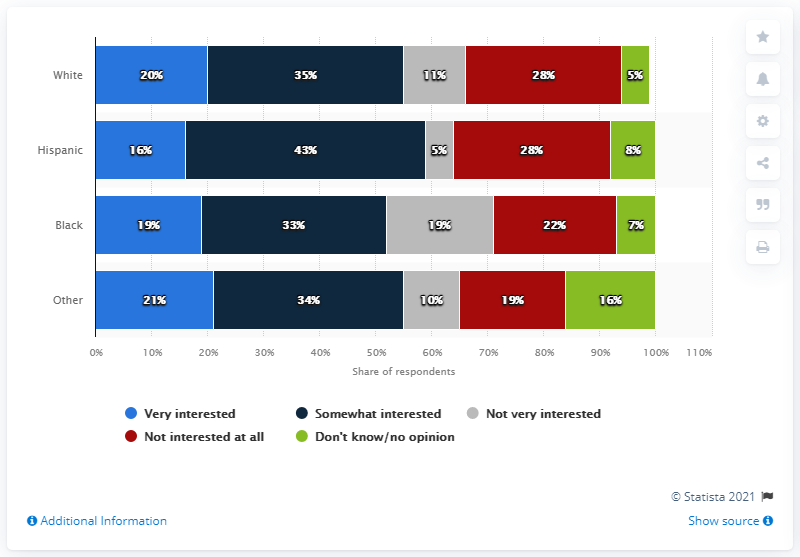List a handful of essential elements in this visual. The navy blue bar has the largest value. 